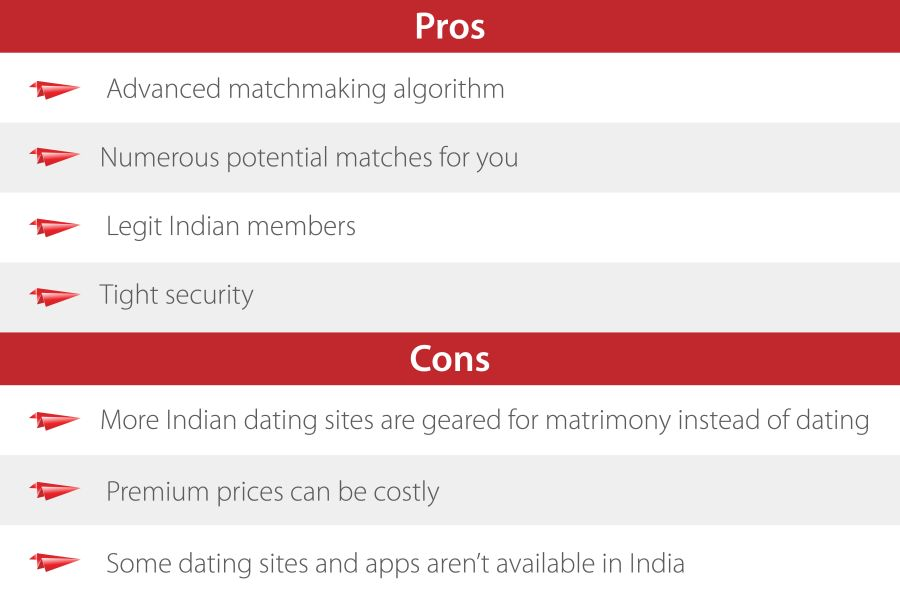What aspects might explain the emphasis on 'tight security' as a benefit in this online dating service? The emphasis on 'tight security' likely addresses potential concerns about privacy and safety that are pertinent to online dating. This feature suggests that the service is committed to protecting personal information and ensuring a secure environment for its members, which is especially important in the context of intimate personal exchanges online. 